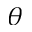<formula> <loc_0><loc_0><loc_500><loc_500>\theta</formula> 